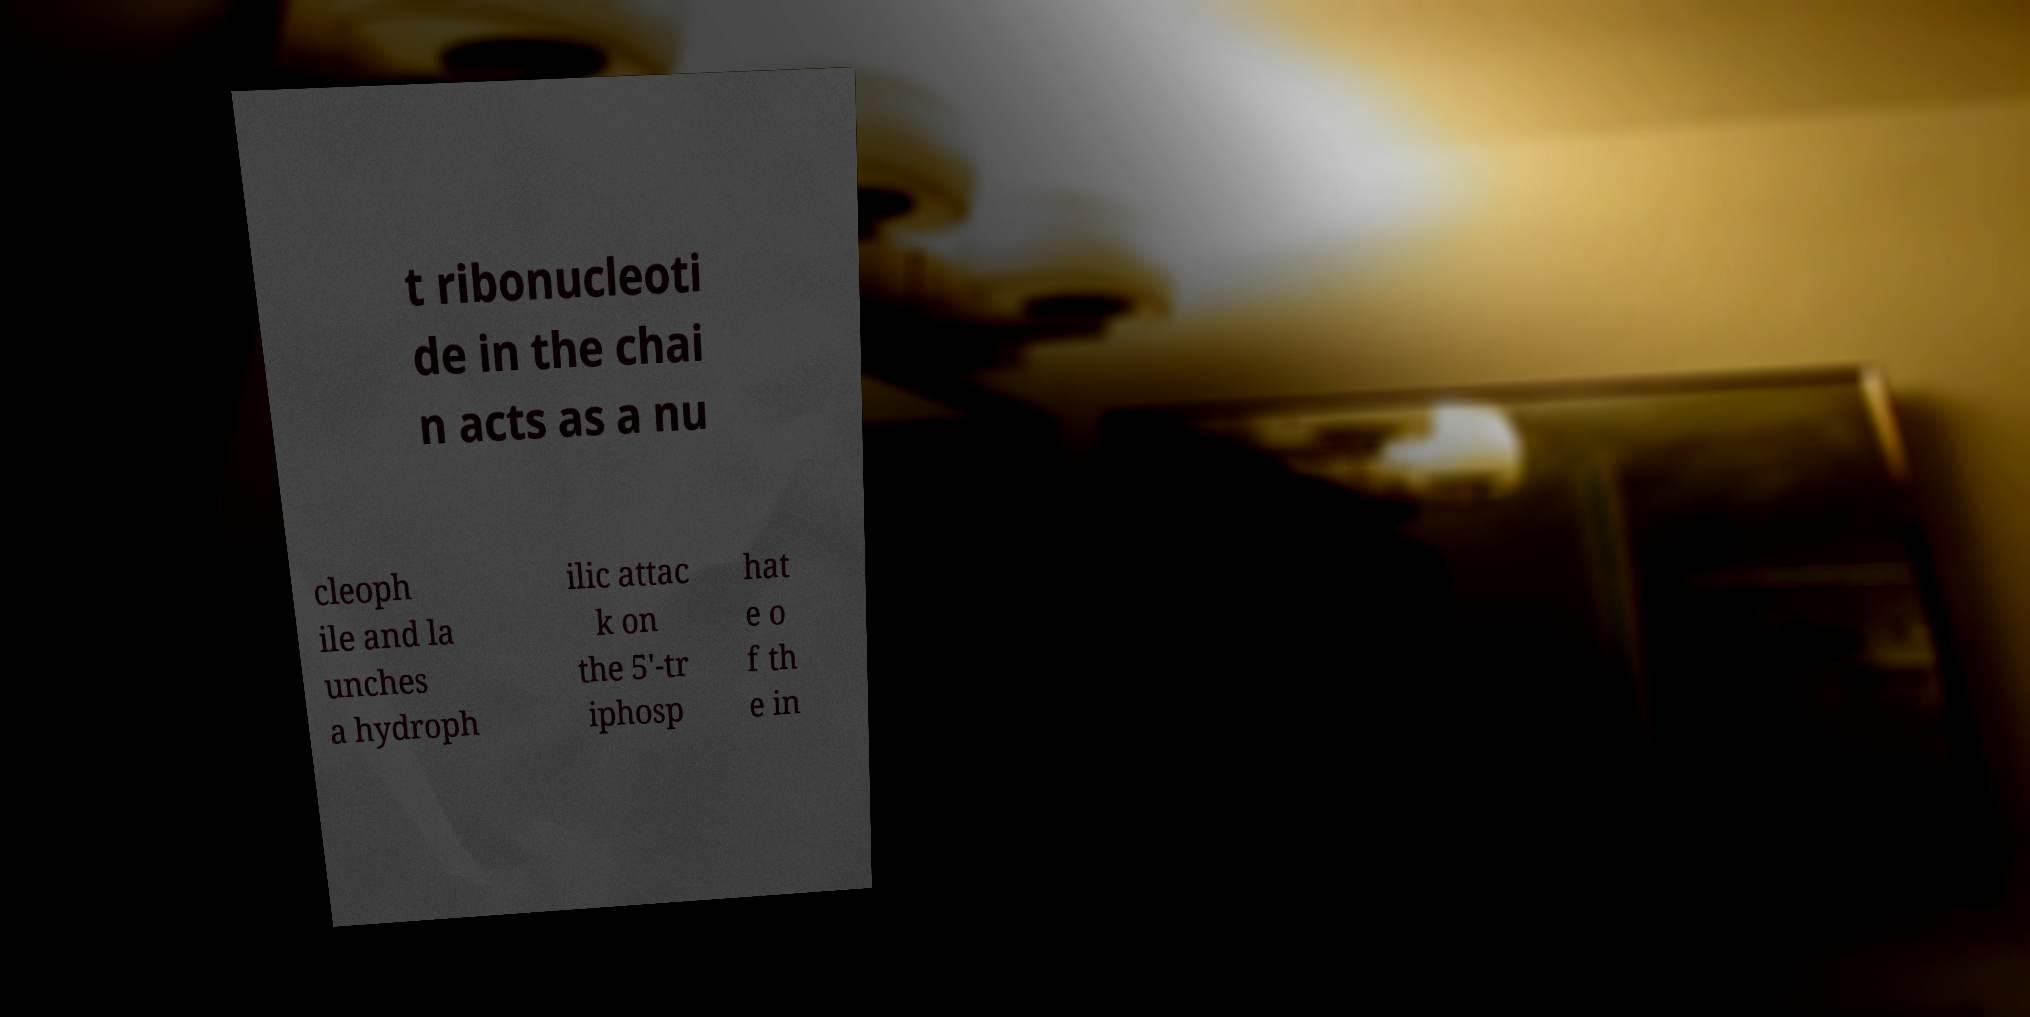Could you assist in decoding the text presented in this image and type it out clearly? t ribonucleoti de in the chai n acts as a nu cleoph ile and la unches a hydroph ilic attac k on the 5'-tr iphosp hat e o f th e in 